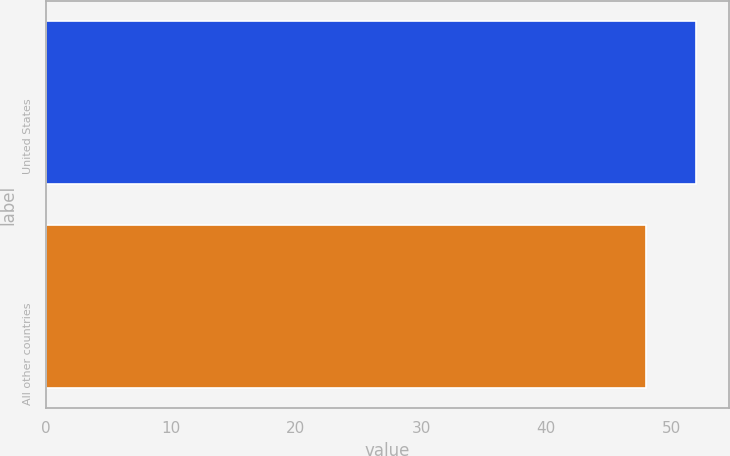<chart> <loc_0><loc_0><loc_500><loc_500><bar_chart><fcel>United States<fcel>All other countries<nl><fcel>52<fcel>48<nl></chart> 